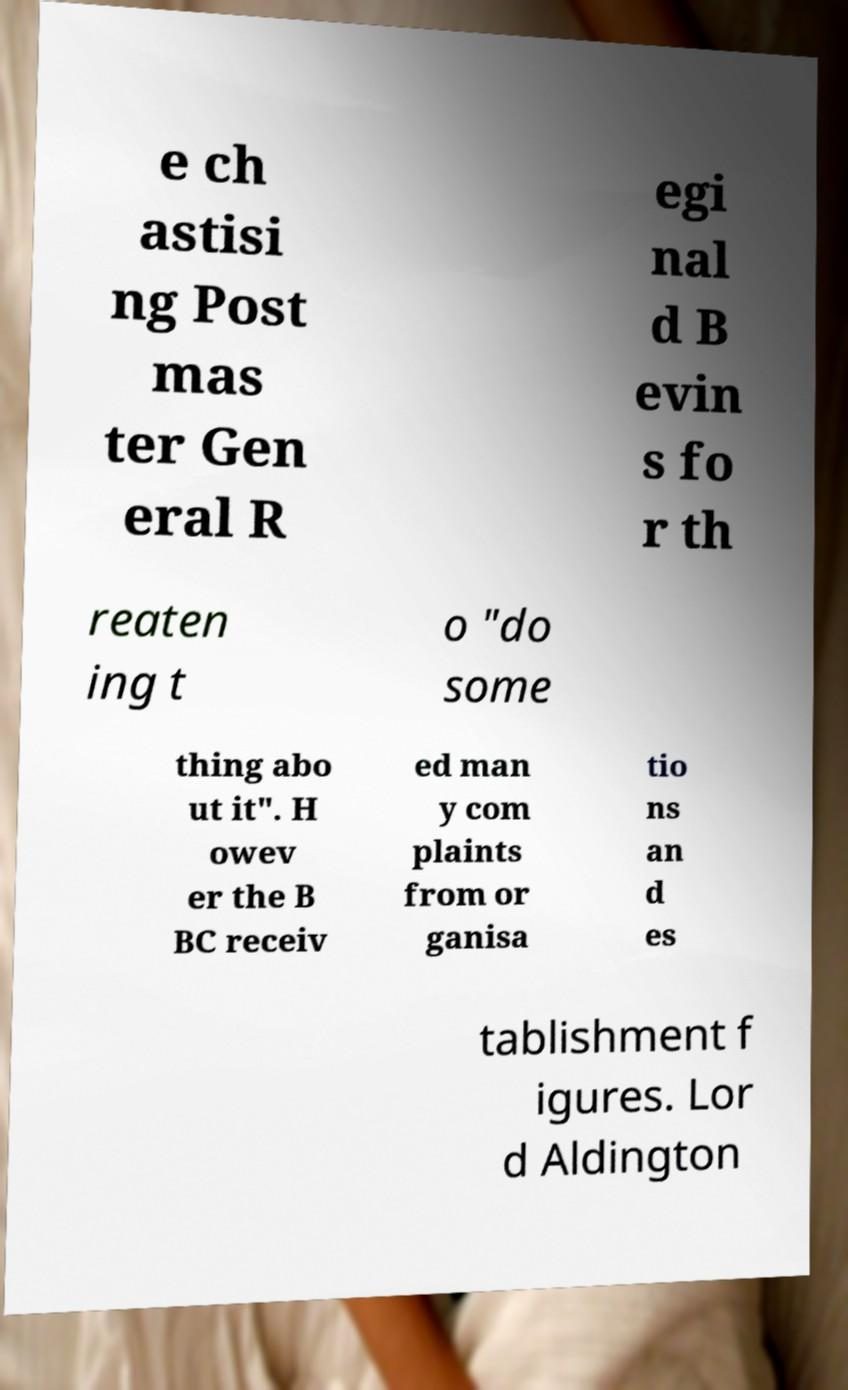Can you accurately transcribe the text from the provided image for me? e ch astisi ng Post mas ter Gen eral R egi nal d B evin s fo r th reaten ing t o "do some thing abo ut it". H owev er the B BC receiv ed man y com plaints from or ganisa tio ns an d es tablishment f igures. Lor d Aldington 